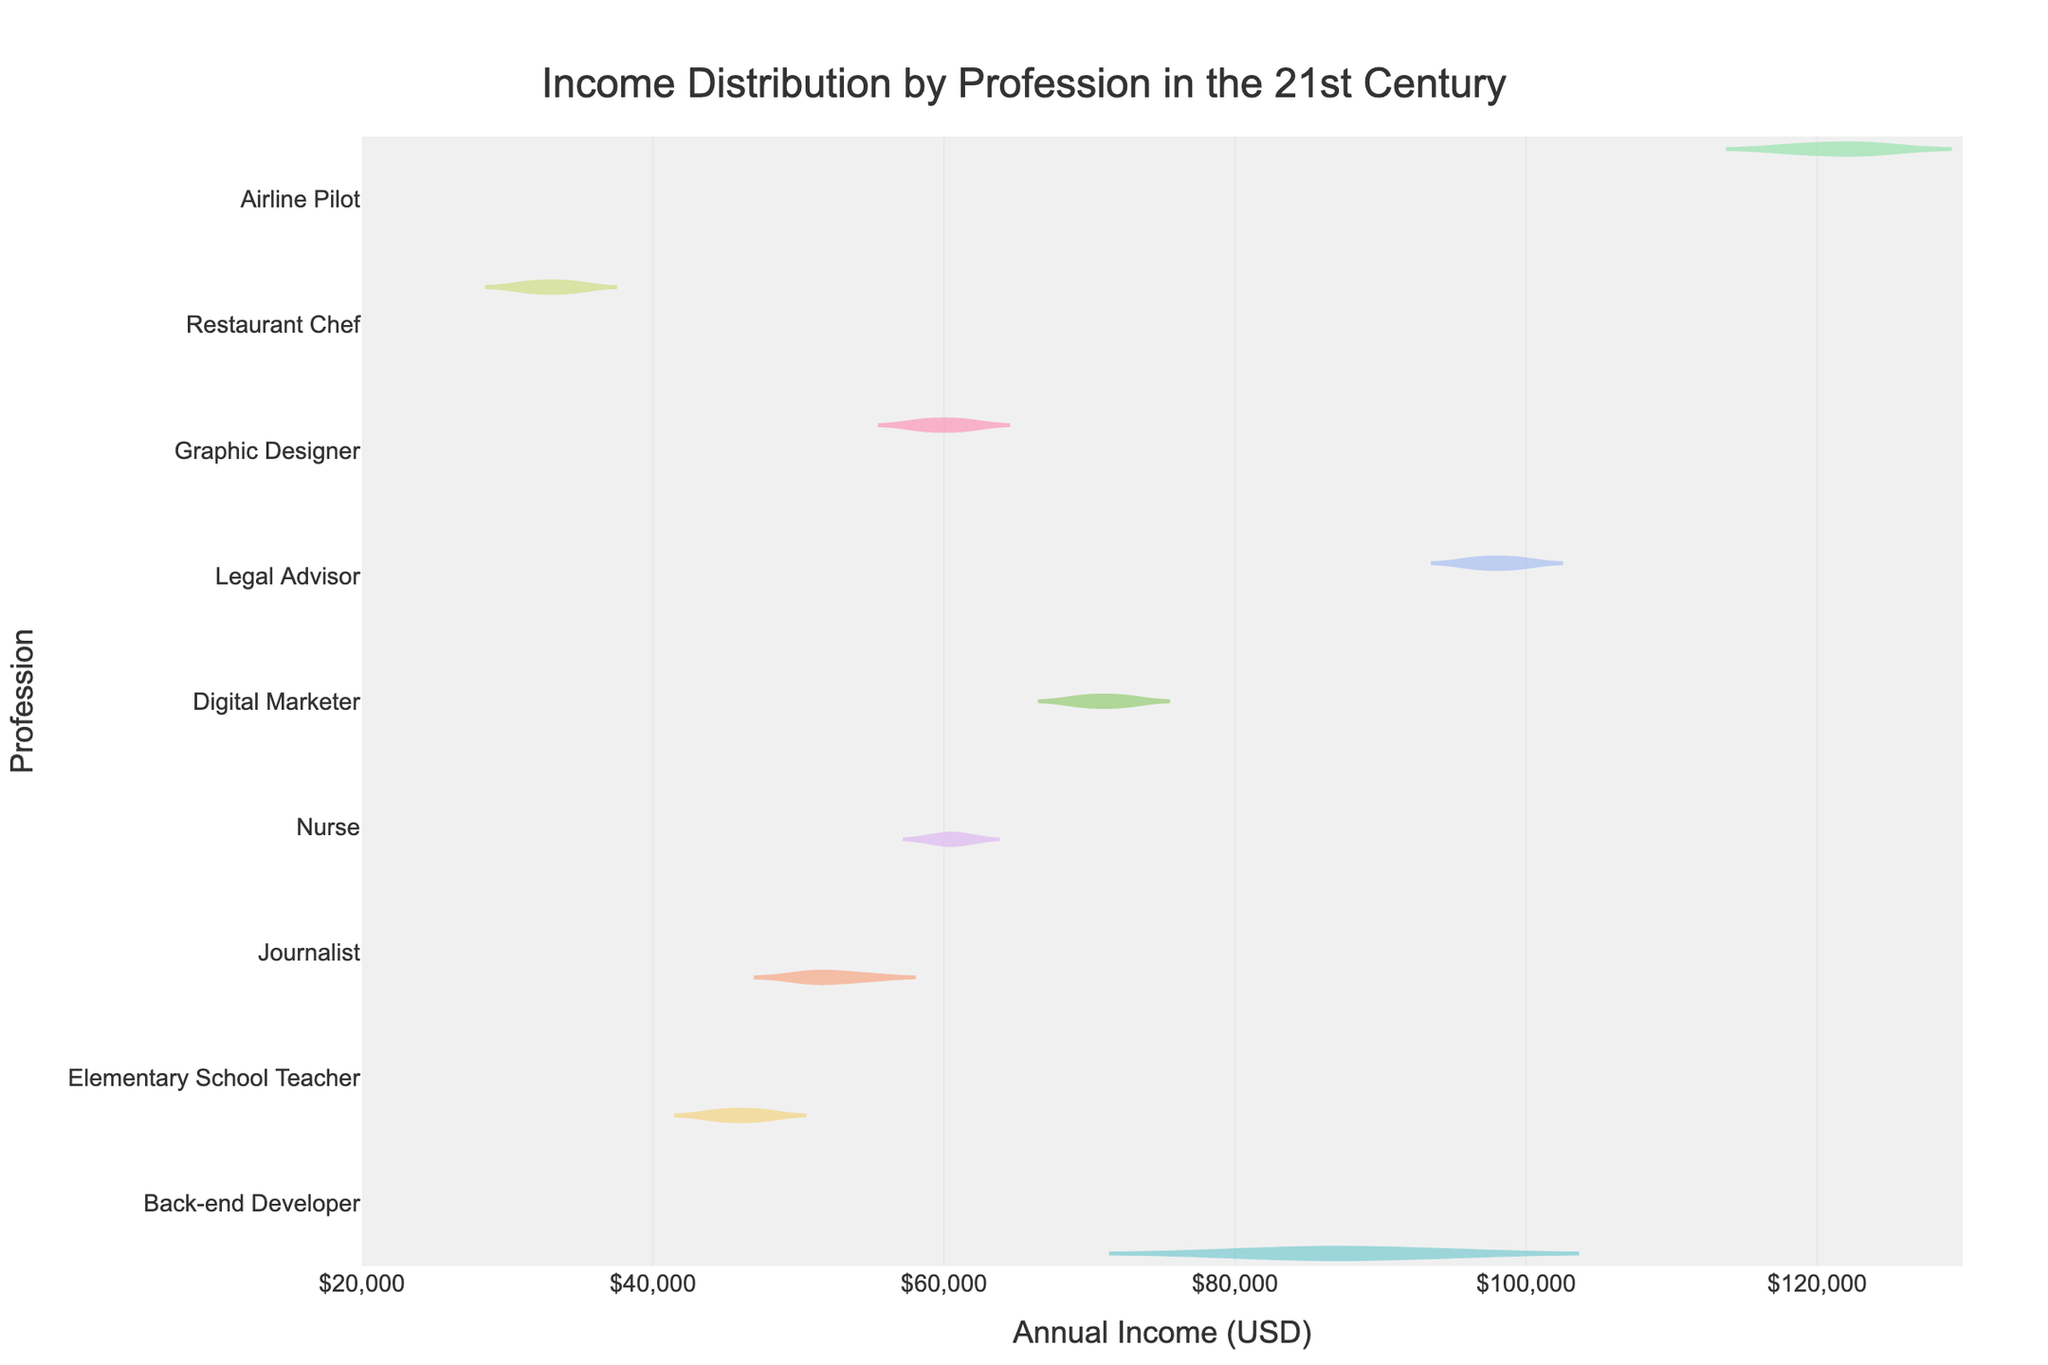What is the title of the figure? The title is typically prominently displayed at the top of the figure. It provides a concise summary of what the figure is illustrating.
Answer: Income Distribution by Profession in the 21st Century What does the x-axis represent in the figure? The x-axis usually has a label indicating what it represents. In this case, it shows the range of incomes in USD.
Answer: Annual Income (USD) Which profession has the highest median income? Examine the median line (the line inside the box) for each profession's distplot. The Airline Pilot profession's median line is positioned the highest on the x-axis.
Answer: Airline Pilot How does the income distribution for Restaurant Chefs compare to Digital Marketers? Compare the spread and center of the distributions for these two professions. Restaurant Chefs have lower overall income with a more narrow distribution, while Digital Marketers have a higher income range and a broader distribution.
Answer: Restaurant Chefs have a lower and narrower distribution compared to Digital Marketers Which profession shows the widest income distribution? Look at the length of the 'violin' plot from the smallest to the largest values. Airline Pilots and Legal Advisors have the widest distributions, but Airline Pilots' range is slightly broader.
Answer: Airline Pilot What is the approximate income range for Elementary School Teachers? Check the lower and upper edges of the Elementary School Teachers' distribution. The range goes from around $44,000 to $48,000.
Answer: $44,000 to $48,000 Are there any professions with a clear outlier in their income distribution? Inspect each violin plot for any points that are distinctly separate from the rest of the distribution. There are no visible outliers in the distributions shown.
Answer: No Which profession shows the least variation in income? The profession with the narrowest violin plot illustrates the least variation. Elementary School Teachers have the narrowest plot.
Answer: Elementary School Teacher Which profession earns close to the middle range of all professions shown? Identify the profession whose median is centrally located on the x-axis. The Nurse's median income is comparatively in the middle of the income ranges portrayed.
Answer: Nurse 